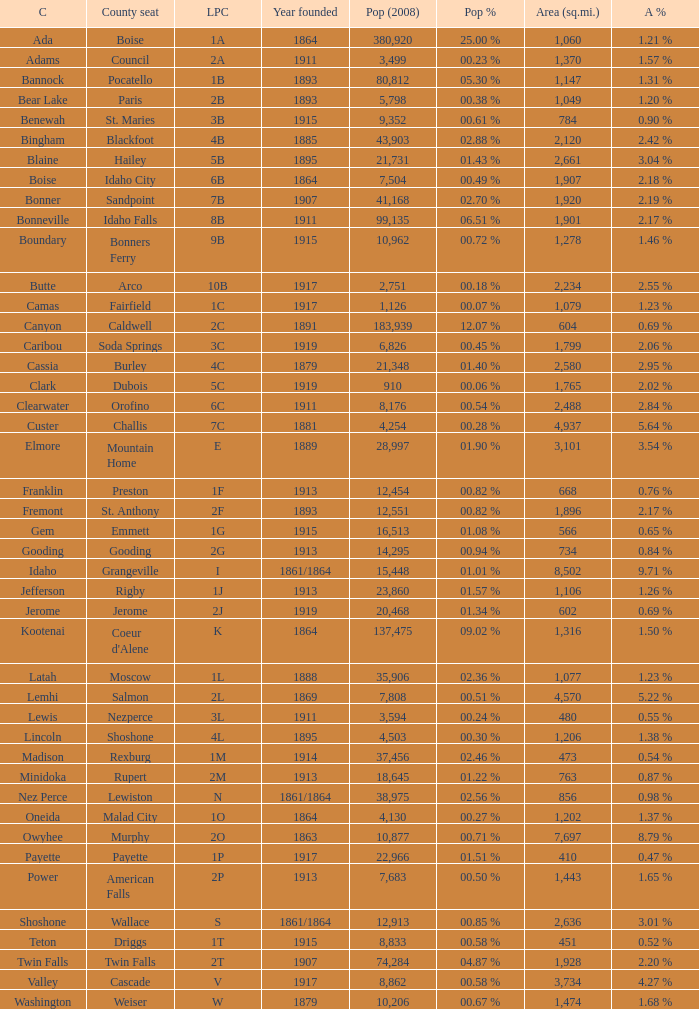What is the country seat for the license plate code 5c? Dubois. 